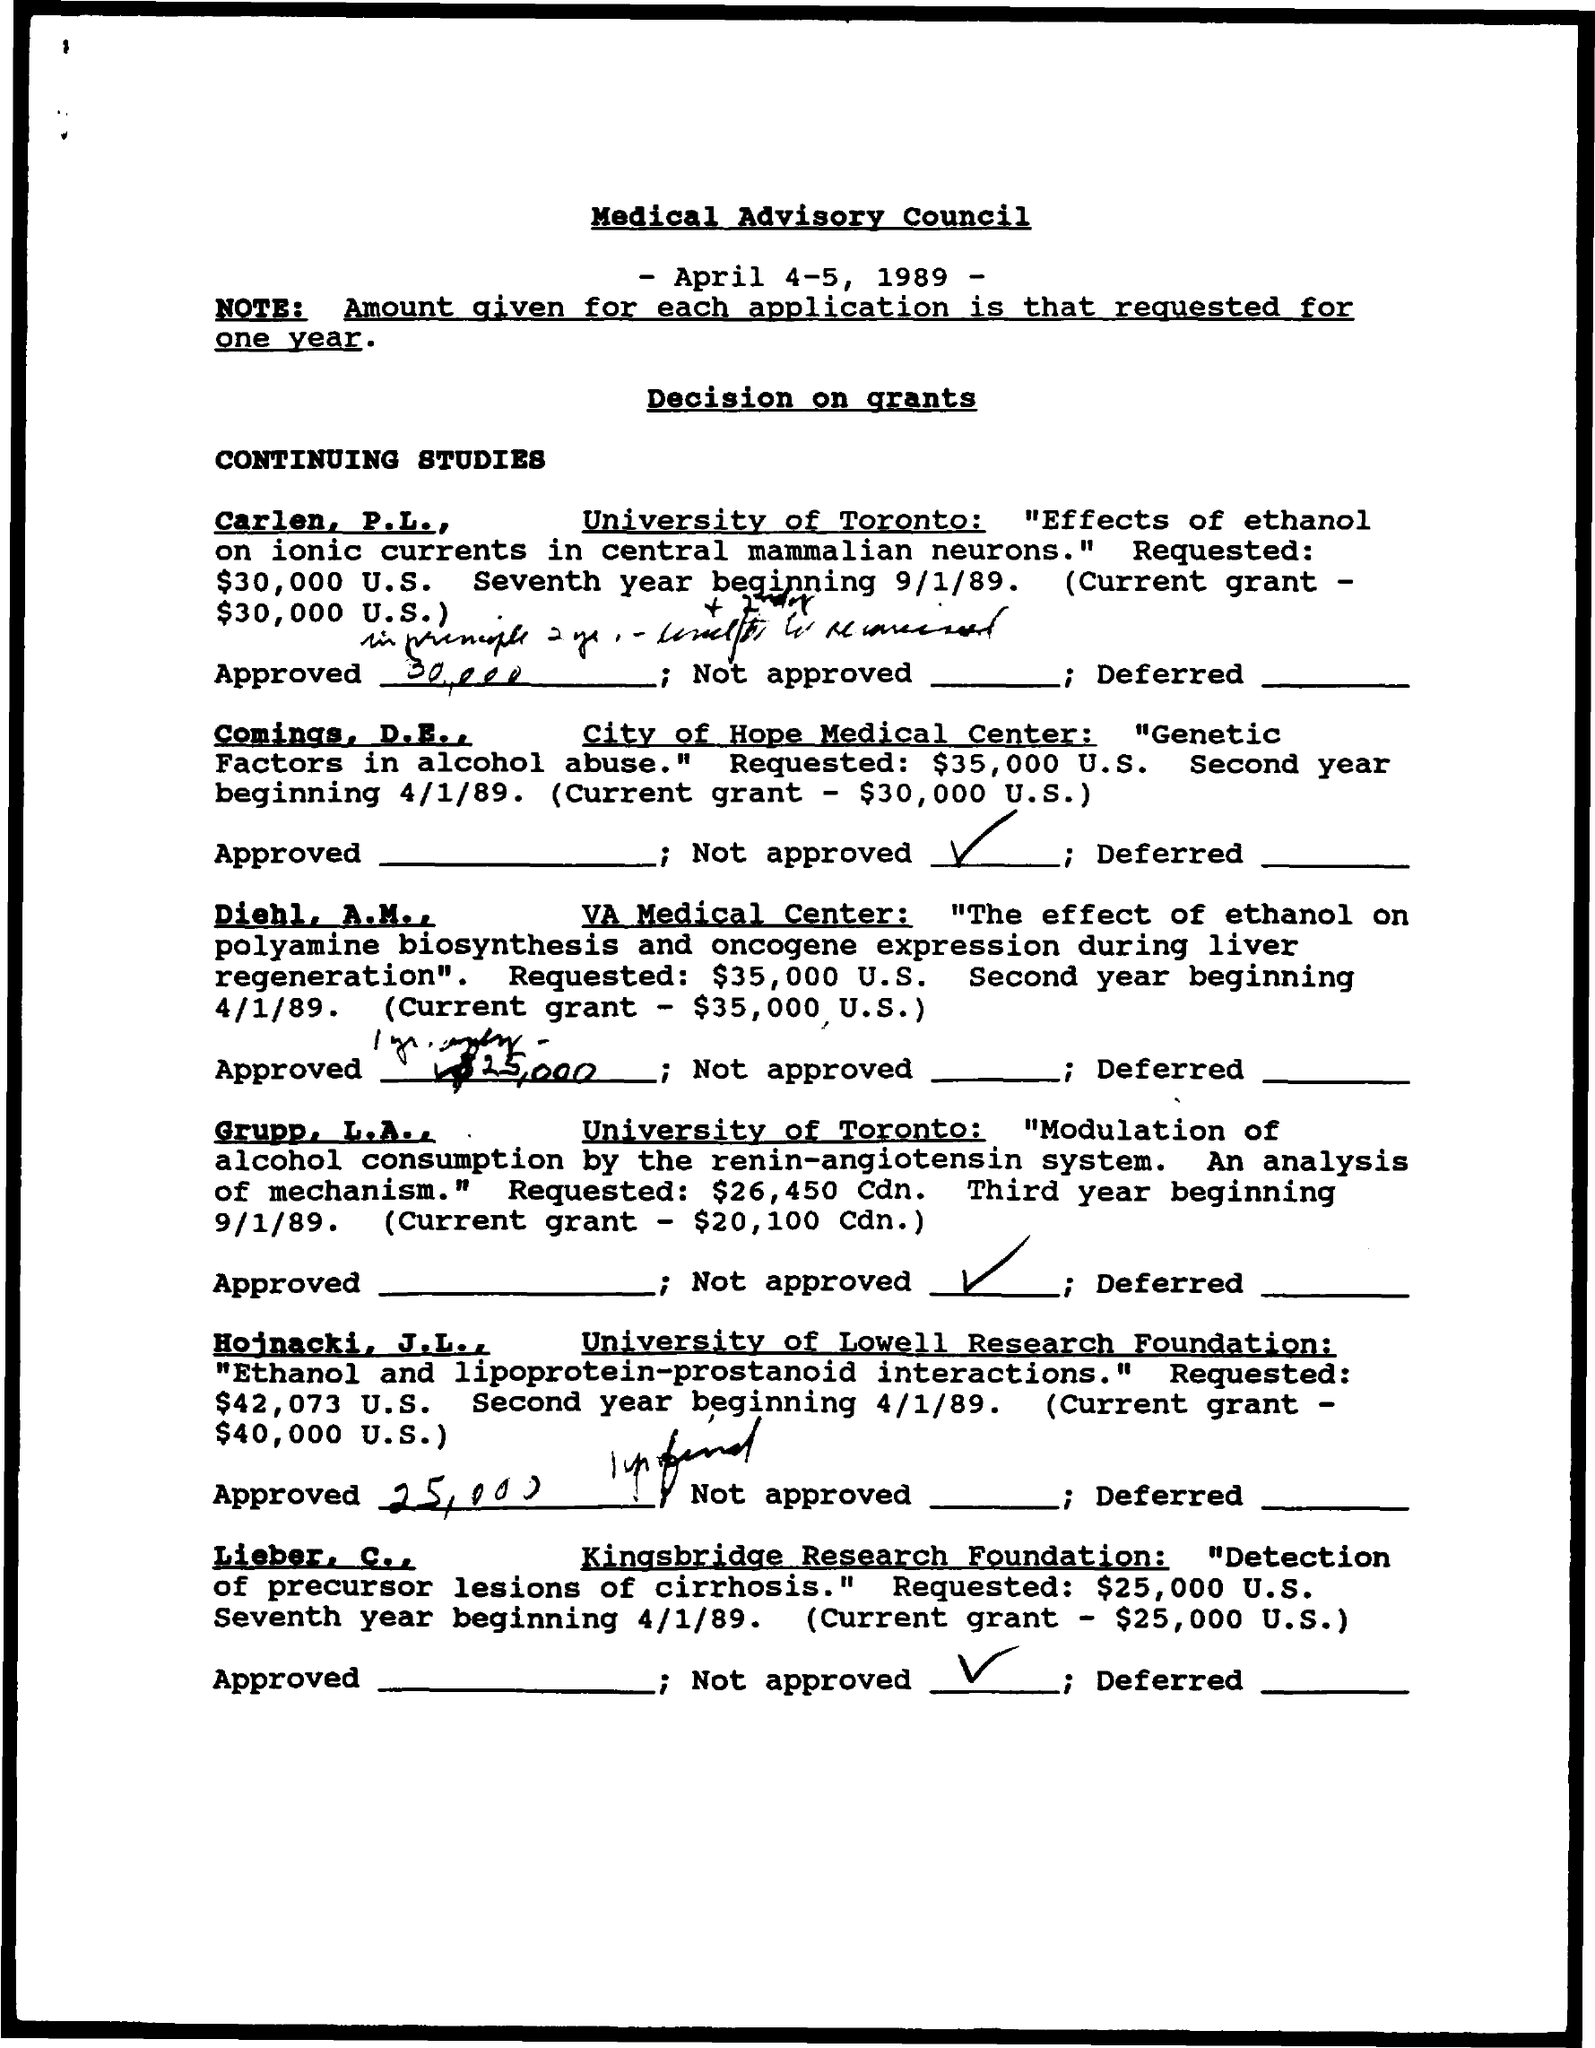Mention a couple of crucial points in this snapshot. The date on the document is April 4th through 5th, 1989. The current grant for Carlen, P.L. is $30,000 USD. The current grant amount for Comings, D.E. is $30,000 USD. 